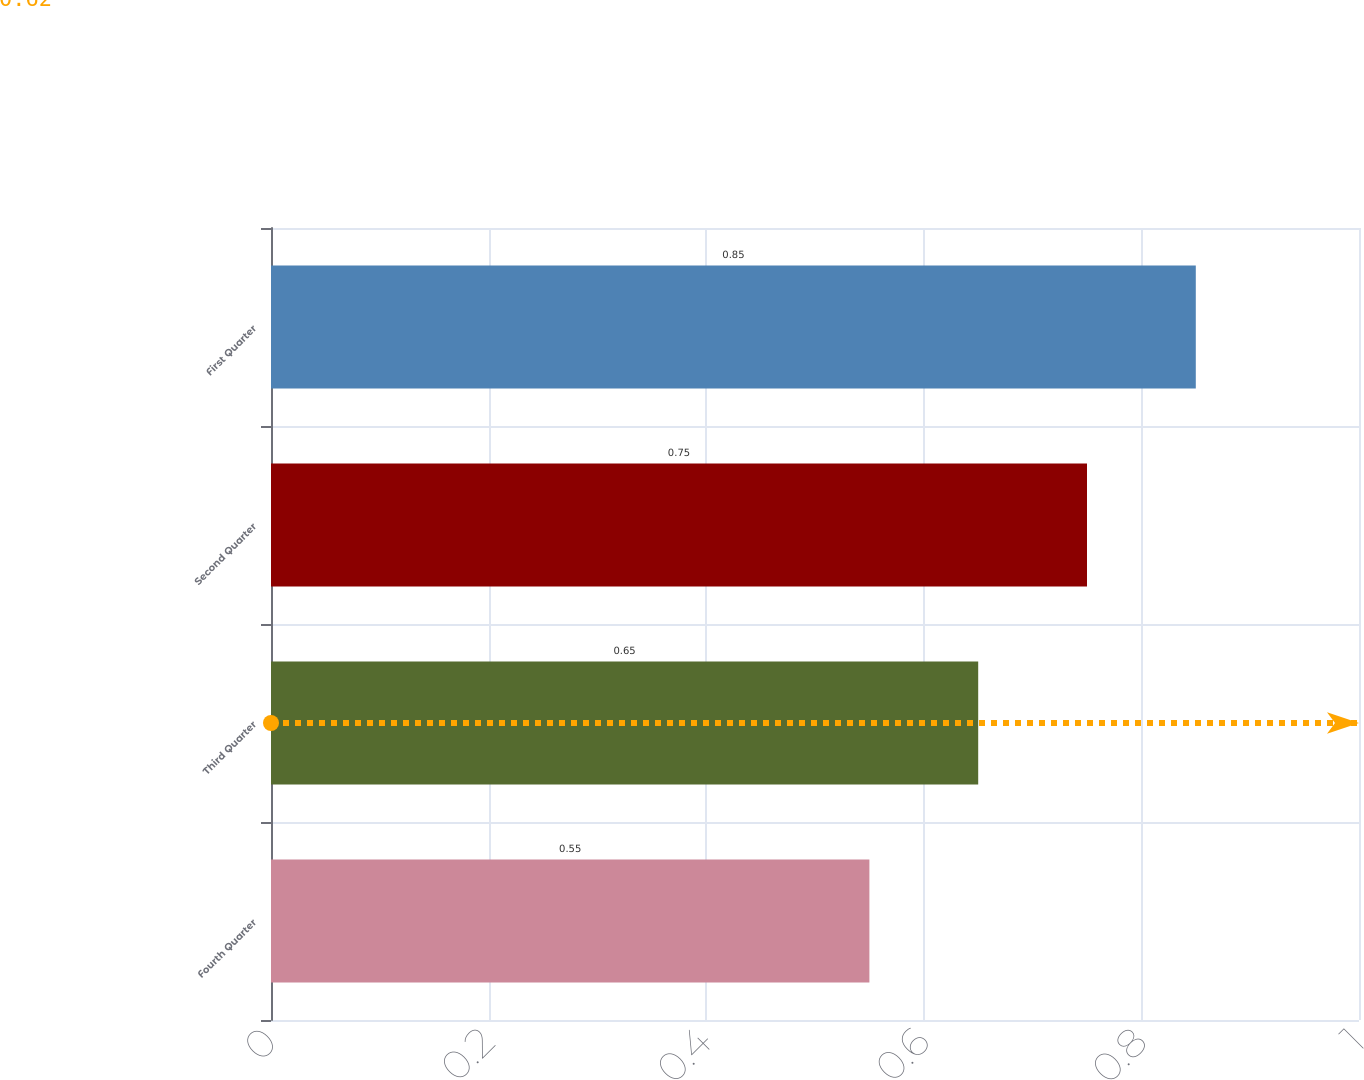Convert chart to OTSL. <chart><loc_0><loc_0><loc_500><loc_500><bar_chart><fcel>Fourth Quarter<fcel>Third Quarter<fcel>Second Quarter<fcel>First Quarter<nl><fcel>0.55<fcel>0.65<fcel>0.75<fcel>0.85<nl></chart> 